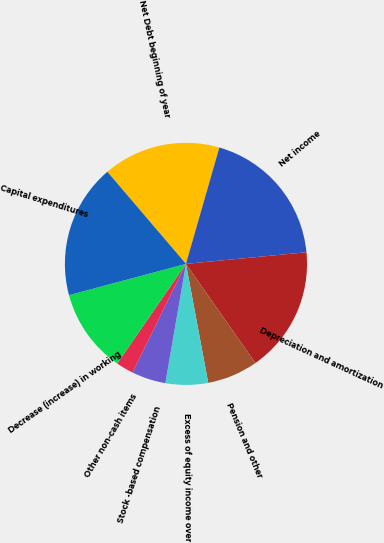<chart> <loc_0><loc_0><loc_500><loc_500><pie_chart><fcel>Net Debt beginning of year<fcel>Net income<fcel>Depreciation and amortization<fcel>Pension and other<fcel>Excess of equity income over<fcel>Stock -based compensation<fcel>Other non-cash items<fcel>Decrease (increase) in working<fcel>Capital expenditures<nl><fcel>15.69%<fcel>19.02%<fcel>16.8%<fcel>6.78%<fcel>5.67%<fcel>4.56%<fcel>2.33%<fcel>11.23%<fcel>17.91%<nl></chart> 